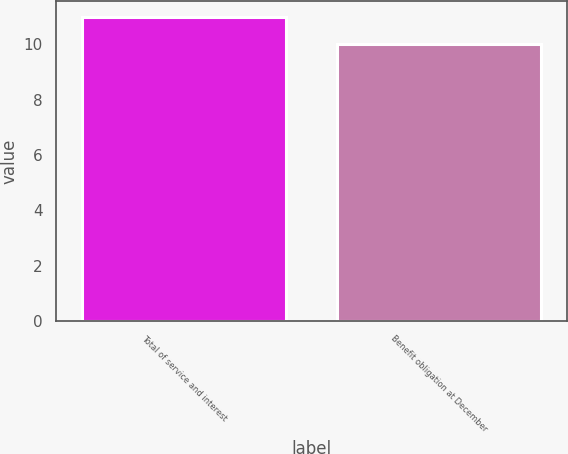Convert chart to OTSL. <chart><loc_0><loc_0><loc_500><loc_500><bar_chart><fcel>Total of service and interest<fcel>Benefit obligation at December<nl><fcel>11<fcel>10<nl></chart> 